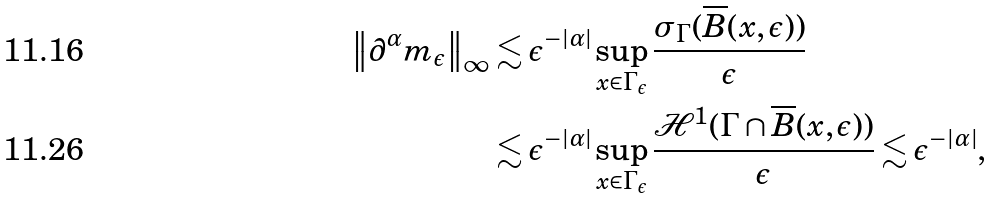<formula> <loc_0><loc_0><loc_500><loc_500>\left \| \partial ^ { \alpha } m _ { \epsilon } \right \| _ { \infty } & \lesssim \epsilon ^ { - | \alpha | } \sup _ { x \in \Gamma _ { \epsilon } } \frac { \sigma _ { \Gamma } ( \overline { B } ( x , \epsilon ) ) } { \epsilon } \\ & \lesssim \epsilon ^ { - | \alpha | } \sup _ { x \in \Gamma _ { \epsilon } } \frac { { \mathcal { H } } ^ { 1 } ( \Gamma \cap \overline { B } ( x , \epsilon ) ) } { \epsilon } \lesssim \epsilon ^ { - | \alpha | } ,</formula> 